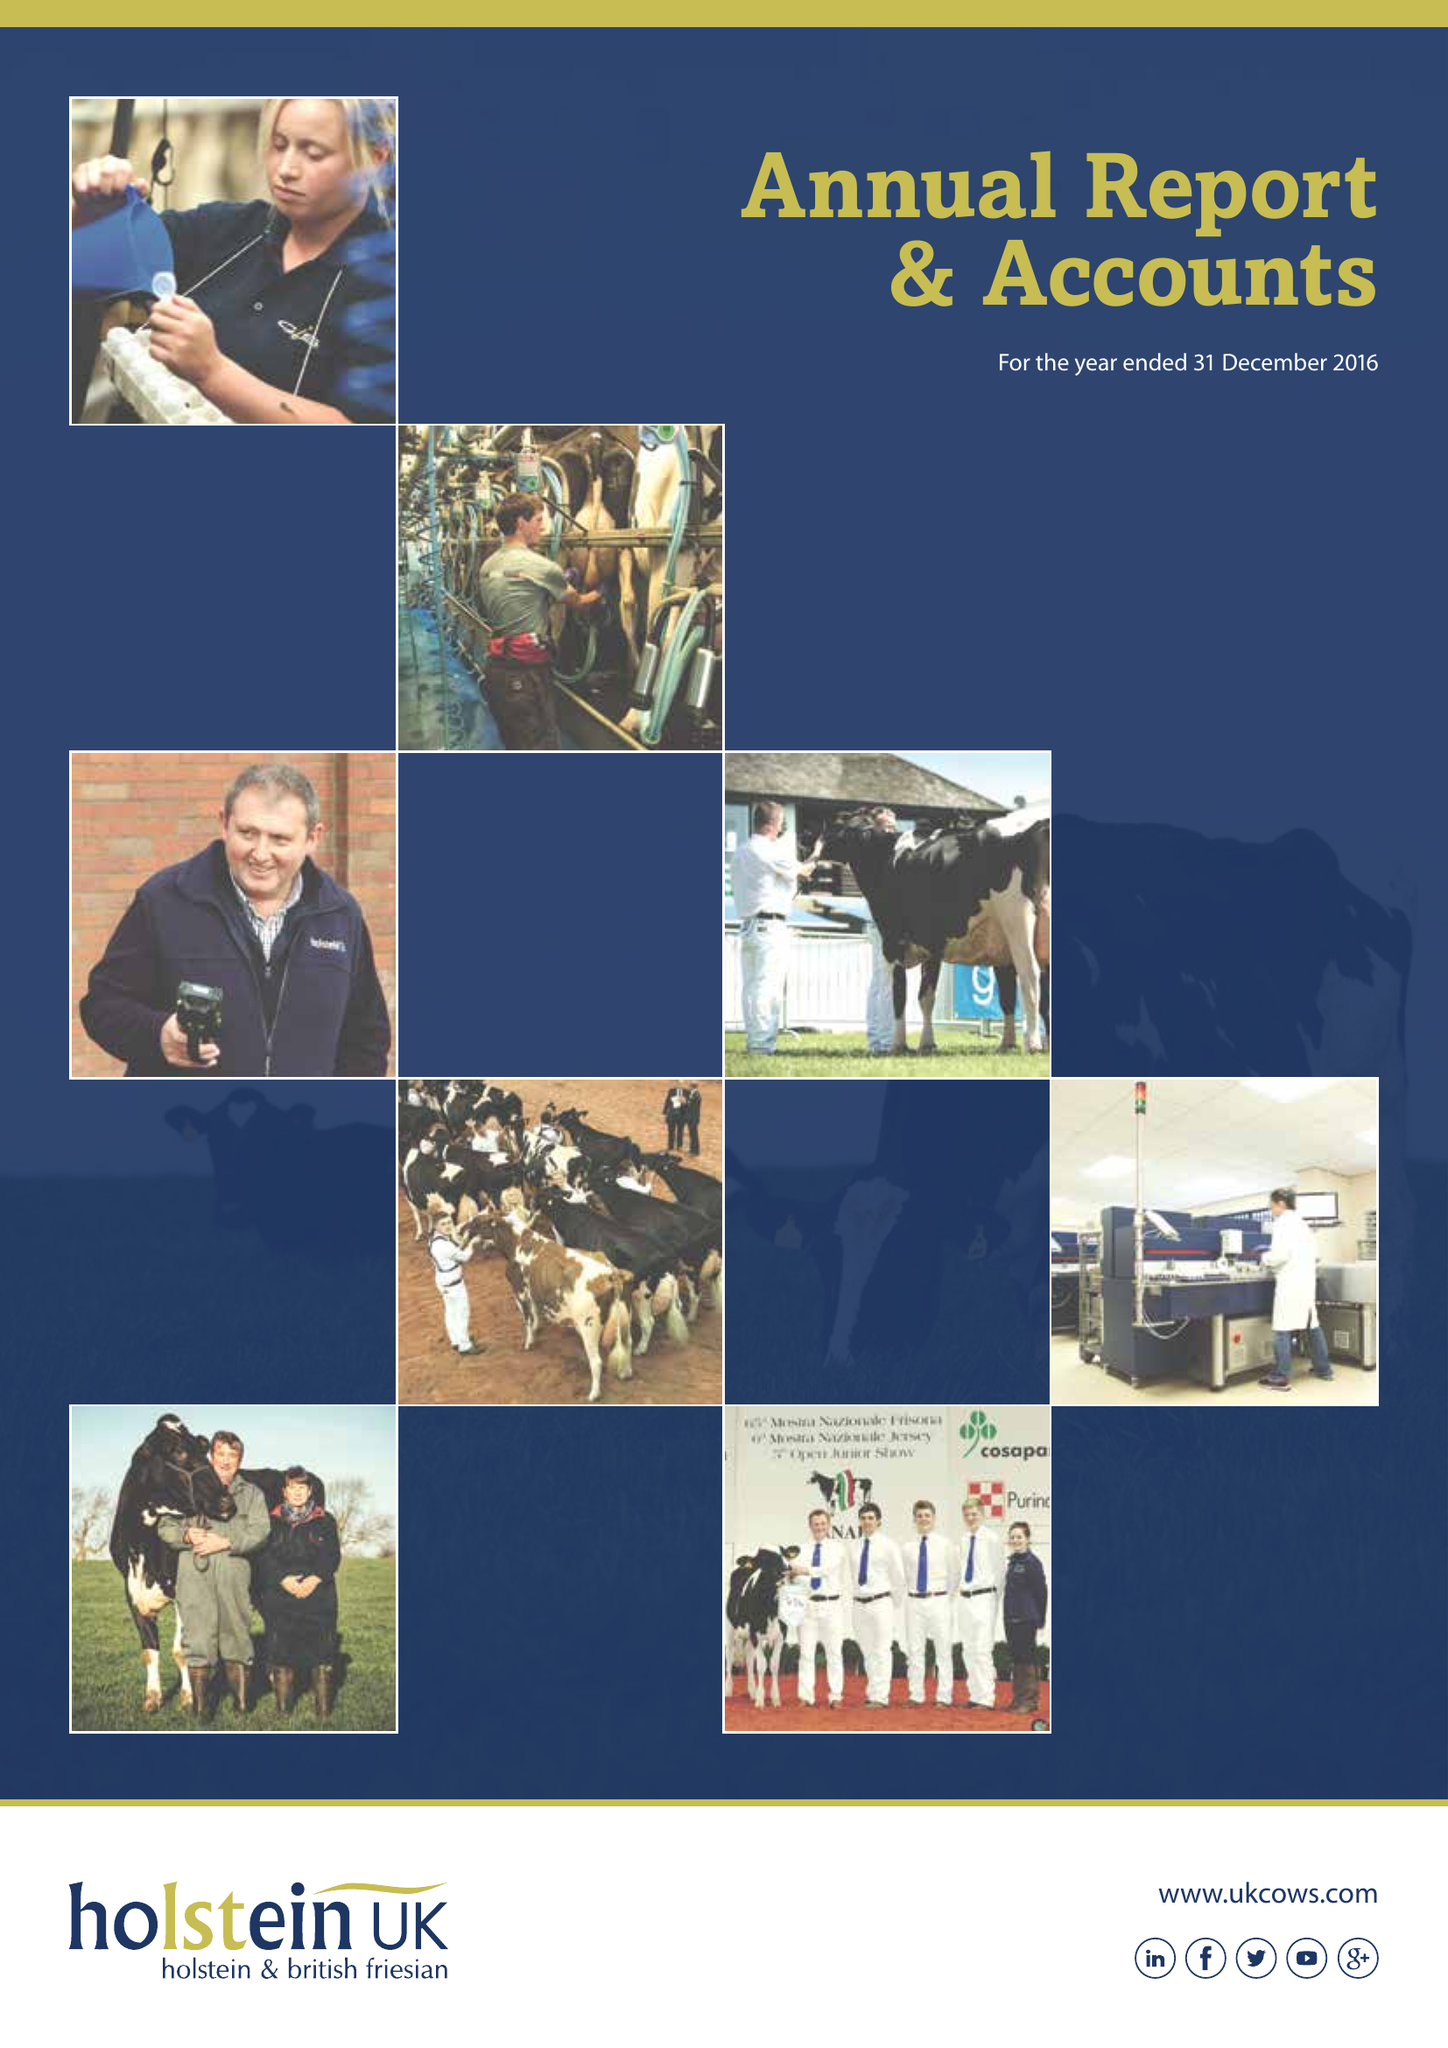What is the value for the address__street_line?
Answer the question using a single word or phrase. STAFFORD PARK 1 